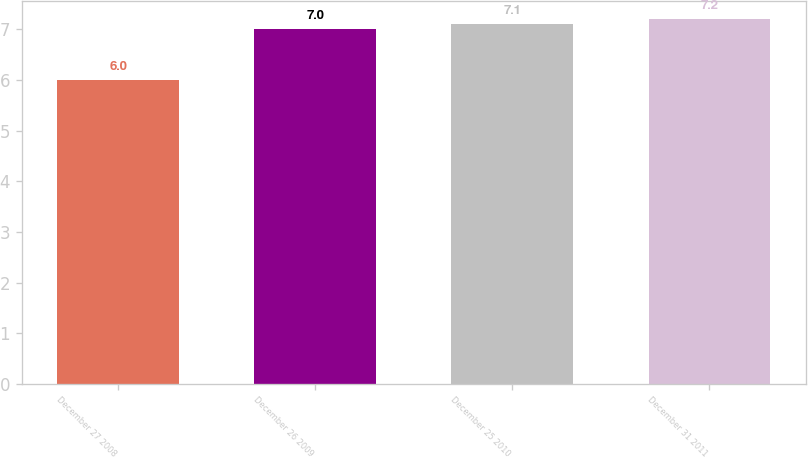Convert chart to OTSL. <chart><loc_0><loc_0><loc_500><loc_500><bar_chart><fcel>December 27 2008<fcel>December 26 2009<fcel>December 25 2010<fcel>December 31 2011<nl><fcel>6<fcel>7<fcel>7.1<fcel>7.2<nl></chart> 